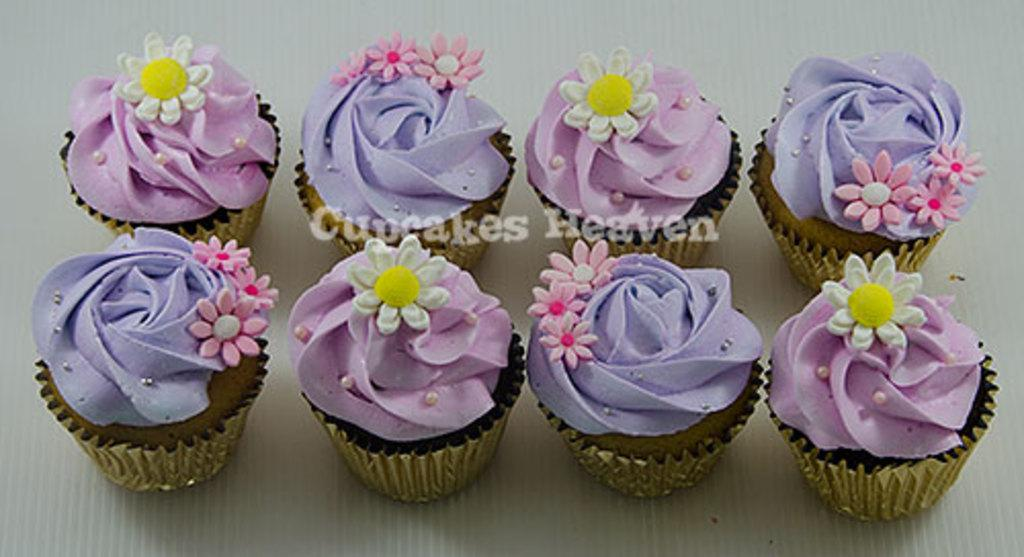How many cupcakes are visible in the image? There are eight cupcakes in the image. What colors are used for the cream on the cupcakes? The cream of the cupcakes is in purple and violet colors. What is the color of the background in the image? The background of the image is white in color. How many knots are tied on the cupcakes in the image? There are no knots present on the cupcakes in the image; they are decorated with cream in purple and violet colors. 